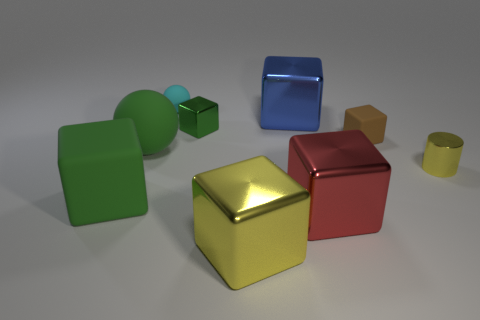Subtract 1 cubes. How many cubes are left? 5 Subtract all red cubes. How many cubes are left? 5 Subtract all green blocks. How many blocks are left? 4 Subtract all gray cubes. Subtract all brown balls. How many cubes are left? 6 Add 1 small yellow shiny objects. How many objects exist? 10 Subtract all cubes. How many objects are left? 3 Subtract 0 gray cylinders. How many objects are left? 9 Subtract all tiny brown things. Subtract all cylinders. How many objects are left? 7 Add 4 large balls. How many large balls are left? 5 Add 6 small metallic cubes. How many small metallic cubes exist? 7 